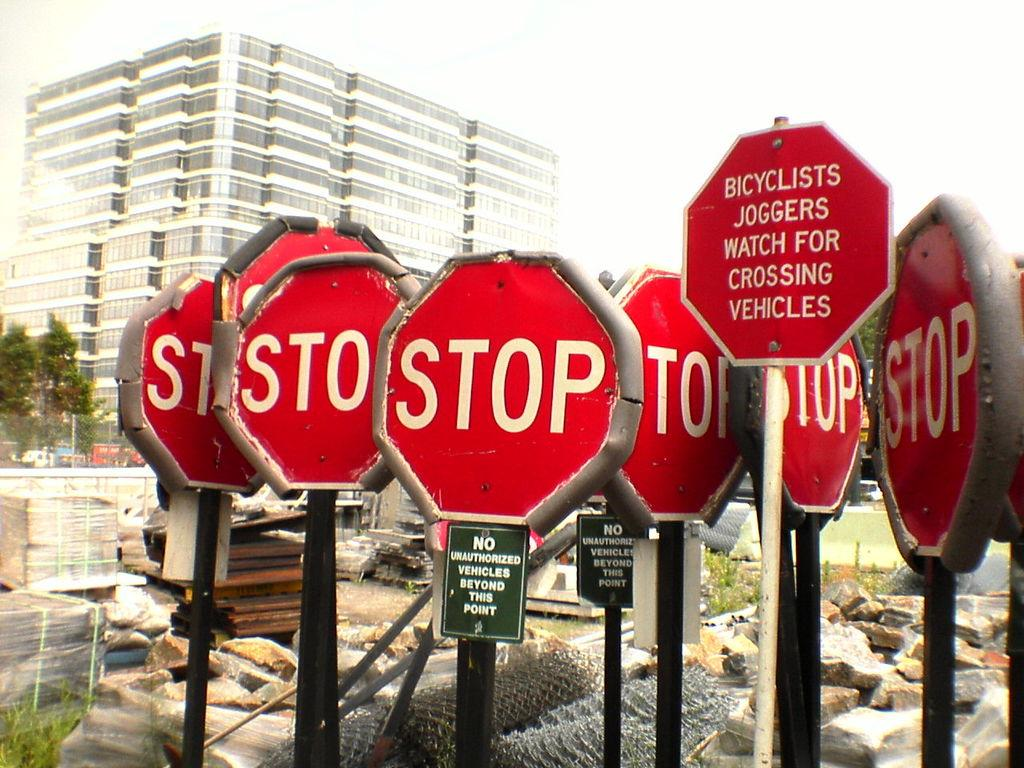<image>
Give a short and clear explanation of the subsequent image. A variety of Red and white signs with the word stop in the middle. 